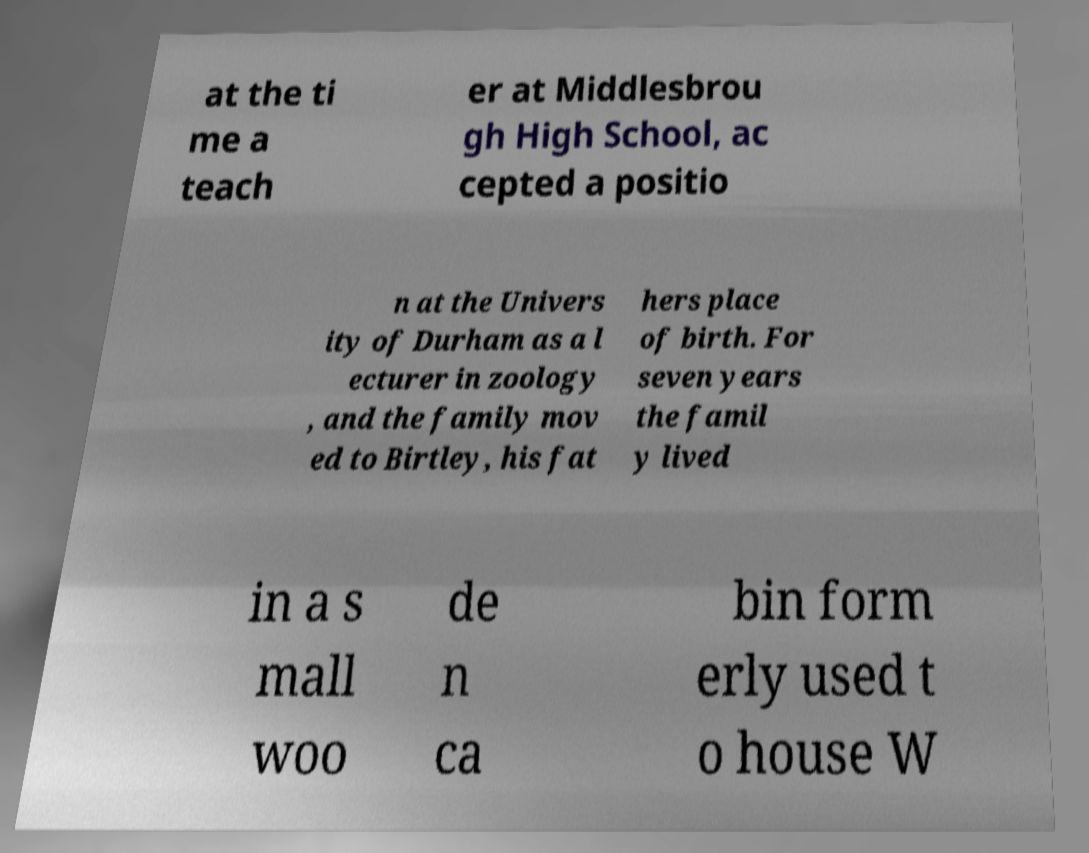There's text embedded in this image that I need extracted. Can you transcribe it verbatim? at the ti me a teach er at Middlesbrou gh High School, ac cepted a positio n at the Univers ity of Durham as a l ecturer in zoology , and the family mov ed to Birtley, his fat hers place of birth. For seven years the famil y lived in a s mall woo de n ca bin form erly used t o house W 